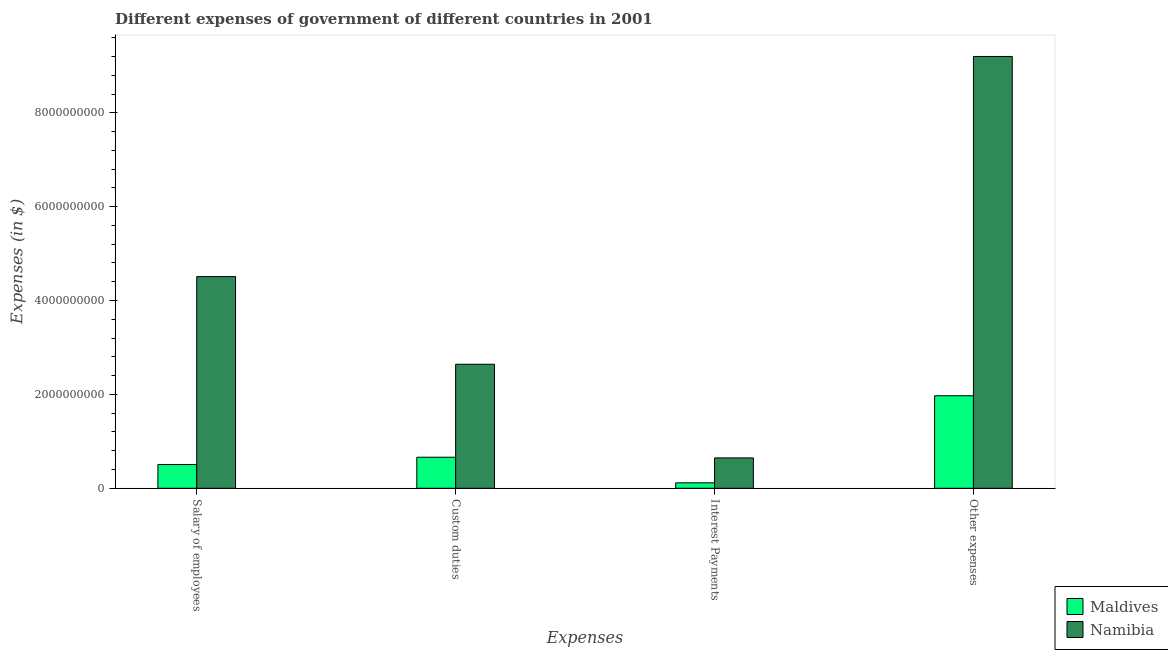Are the number of bars per tick equal to the number of legend labels?
Offer a very short reply. Yes. How many bars are there on the 3rd tick from the left?
Provide a short and direct response. 2. What is the label of the 2nd group of bars from the left?
Provide a short and direct response. Custom duties. What is the amount spent on interest payments in Namibia?
Provide a succinct answer. 6.47e+08. Across all countries, what is the maximum amount spent on interest payments?
Make the answer very short. 6.47e+08. Across all countries, what is the minimum amount spent on interest payments?
Offer a terse response. 1.16e+08. In which country was the amount spent on salary of employees maximum?
Offer a very short reply. Namibia. In which country was the amount spent on other expenses minimum?
Ensure brevity in your answer.  Maldives. What is the total amount spent on salary of employees in the graph?
Provide a short and direct response. 5.02e+09. What is the difference between the amount spent on other expenses in Namibia and that in Maldives?
Offer a very short reply. 7.23e+09. What is the difference between the amount spent on other expenses in Namibia and the amount spent on interest payments in Maldives?
Provide a succinct answer. 9.08e+09. What is the average amount spent on salary of employees per country?
Offer a terse response. 2.51e+09. What is the difference between the amount spent on salary of employees and amount spent on other expenses in Maldives?
Offer a terse response. -1.47e+09. In how many countries, is the amount spent on other expenses greater than 1200000000 $?
Ensure brevity in your answer.  2. What is the ratio of the amount spent on custom duties in Namibia to that in Maldives?
Offer a terse response. 3.99. What is the difference between the highest and the second highest amount spent on salary of employees?
Make the answer very short. 4.00e+09. What is the difference between the highest and the lowest amount spent on custom duties?
Ensure brevity in your answer.  1.98e+09. In how many countries, is the amount spent on custom duties greater than the average amount spent on custom duties taken over all countries?
Give a very brief answer. 1. Is it the case that in every country, the sum of the amount spent on salary of employees and amount spent on interest payments is greater than the sum of amount spent on custom duties and amount spent on other expenses?
Give a very brief answer. No. What does the 1st bar from the left in Custom duties represents?
Give a very brief answer. Maldives. What does the 2nd bar from the right in Custom duties represents?
Your response must be concise. Maldives. Is it the case that in every country, the sum of the amount spent on salary of employees and amount spent on custom duties is greater than the amount spent on interest payments?
Offer a terse response. Yes. How many bars are there?
Give a very brief answer. 8. Are all the bars in the graph horizontal?
Your answer should be compact. No. What is the difference between two consecutive major ticks on the Y-axis?
Your answer should be compact. 2.00e+09. Are the values on the major ticks of Y-axis written in scientific E-notation?
Offer a terse response. No. Does the graph contain grids?
Give a very brief answer. No. How many legend labels are there?
Your answer should be compact. 2. How are the legend labels stacked?
Offer a terse response. Vertical. What is the title of the graph?
Give a very brief answer. Different expenses of government of different countries in 2001. Does "Northern Mariana Islands" appear as one of the legend labels in the graph?
Offer a very short reply. No. What is the label or title of the X-axis?
Keep it short and to the point. Expenses. What is the label or title of the Y-axis?
Offer a terse response. Expenses (in $). What is the Expenses (in $) in Maldives in Salary of employees?
Make the answer very short. 5.06e+08. What is the Expenses (in $) of Namibia in Salary of employees?
Provide a succinct answer. 4.51e+09. What is the Expenses (in $) in Maldives in Custom duties?
Provide a succinct answer. 6.62e+08. What is the Expenses (in $) in Namibia in Custom duties?
Offer a very short reply. 2.64e+09. What is the Expenses (in $) of Maldives in Interest Payments?
Make the answer very short. 1.16e+08. What is the Expenses (in $) of Namibia in Interest Payments?
Give a very brief answer. 6.47e+08. What is the Expenses (in $) of Maldives in Other expenses?
Give a very brief answer. 1.97e+09. What is the Expenses (in $) in Namibia in Other expenses?
Provide a succinct answer. 9.20e+09. Across all Expenses, what is the maximum Expenses (in $) of Maldives?
Ensure brevity in your answer.  1.97e+09. Across all Expenses, what is the maximum Expenses (in $) of Namibia?
Your response must be concise. 9.20e+09. Across all Expenses, what is the minimum Expenses (in $) in Maldives?
Offer a very short reply. 1.16e+08. Across all Expenses, what is the minimum Expenses (in $) in Namibia?
Provide a short and direct response. 6.47e+08. What is the total Expenses (in $) of Maldives in the graph?
Keep it short and to the point. 3.26e+09. What is the total Expenses (in $) of Namibia in the graph?
Your response must be concise. 1.70e+1. What is the difference between the Expenses (in $) of Maldives in Salary of employees and that in Custom duties?
Offer a terse response. -1.56e+08. What is the difference between the Expenses (in $) in Namibia in Salary of employees and that in Custom duties?
Offer a very short reply. 1.87e+09. What is the difference between the Expenses (in $) of Maldives in Salary of employees and that in Interest Payments?
Offer a very short reply. 3.89e+08. What is the difference between the Expenses (in $) in Namibia in Salary of employees and that in Interest Payments?
Make the answer very short. 3.86e+09. What is the difference between the Expenses (in $) of Maldives in Salary of employees and that in Other expenses?
Give a very brief answer. -1.47e+09. What is the difference between the Expenses (in $) in Namibia in Salary of employees and that in Other expenses?
Ensure brevity in your answer.  -4.69e+09. What is the difference between the Expenses (in $) in Maldives in Custom duties and that in Interest Payments?
Offer a very short reply. 5.45e+08. What is the difference between the Expenses (in $) in Namibia in Custom duties and that in Interest Payments?
Offer a very short reply. 2.00e+09. What is the difference between the Expenses (in $) of Maldives in Custom duties and that in Other expenses?
Offer a terse response. -1.31e+09. What is the difference between the Expenses (in $) in Namibia in Custom duties and that in Other expenses?
Offer a terse response. -6.56e+09. What is the difference between the Expenses (in $) of Maldives in Interest Payments and that in Other expenses?
Keep it short and to the point. -1.85e+09. What is the difference between the Expenses (in $) in Namibia in Interest Payments and that in Other expenses?
Give a very brief answer. -8.55e+09. What is the difference between the Expenses (in $) of Maldives in Salary of employees and the Expenses (in $) of Namibia in Custom duties?
Make the answer very short. -2.14e+09. What is the difference between the Expenses (in $) of Maldives in Salary of employees and the Expenses (in $) of Namibia in Interest Payments?
Your answer should be compact. -1.41e+08. What is the difference between the Expenses (in $) of Maldives in Salary of employees and the Expenses (in $) of Namibia in Other expenses?
Keep it short and to the point. -8.69e+09. What is the difference between the Expenses (in $) in Maldives in Custom duties and the Expenses (in $) in Namibia in Interest Payments?
Your response must be concise. 1.44e+07. What is the difference between the Expenses (in $) in Maldives in Custom duties and the Expenses (in $) in Namibia in Other expenses?
Your answer should be compact. -8.54e+09. What is the difference between the Expenses (in $) of Maldives in Interest Payments and the Expenses (in $) of Namibia in Other expenses?
Make the answer very short. -9.08e+09. What is the average Expenses (in $) of Maldives per Expenses?
Your answer should be compact. 8.14e+08. What is the average Expenses (in $) in Namibia per Expenses?
Your answer should be very brief. 4.25e+09. What is the difference between the Expenses (in $) in Maldives and Expenses (in $) in Namibia in Salary of employees?
Make the answer very short. -4.00e+09. What is the difference between the Expenses (in $) of Maldives and Expenses (in $) of Namibia in Custom duties?
Make the answer very short. -1.98e+09. What is the difference between the Expenses (in $) in Maldives and Expenses (in $) in Namibia in Interest Payments?
Provide a succinct answer. -5.31e+08. What is the difference between the Expenses (in $) in Maldives and Expenses (in $) in Namibia in Other expenses?
Provide a succinct answer. -7.23e+09. What is the ratio of the Expenses (in $) in Maldives in Salary of employees to that in Custom duties?
Make the answer very short. 0.76. What is the ratio of the Expenses (in $) of Namibia in Salary of employees to that in Custom duties?
Keep it short and to the point. 1.71. What is the ratio of the Expenses (in $) in Maldives in Salary of employees to that in Interest Payments?
Your answer should be very brief. 4.34. What is the ratio of the Expenses (in $) of Namibia in Salary of employees to that in Interest Payments?
Keep it short and to the point. 6.97. What is the ratio of the Expenses (in $) in Maldives in Salary of employees to that in Other expenses?
Provide a short and direct response. 0.26. What is the ratio of the Expenses (in $) in Namibia in Salary of employees to that in Other expenses?
Give a very brief answer. 0.49. What is the ratio of the Expenses (in $) of Maldives in Custom duties to that in Interest Payments?
Make the answer very short. 5.68. What is the ratio of the Expenses (in $) of Namibia in Custom duties to that in Interest Payments?
Offer a very short reply. 4.08. What is the ratio of the Expenses (in $) in Maldives in Custom duties to that in Other expenses?
Your answer should be compact. 0.34. What is the ratio of the Expenses (in $) in Namibia in Custom duties to that in Other expenses?
Your answer should be compact. 0.29. What is the ratio of the Expenses (in $) in Maldives in Interest Payments to that in Other expenses?
Your response must be concise. 0.06. What is the ratio of the Expenses (in $) in Namibia in Interest Payments to that in Other expenses?
Your answer should be very brief. 0.07. What is the difference between the highest and the second highest Expenses (in $) in Maldives?
Keep it short and to the point. 1.31e+09. What is the difference between the highest and the second highest Expenses (in $) in Namibia?
Give a very brief answer. 4.69e+09. What is the difference between the highest and the lowest Expenses (in $) of Maldives?
Offer a very short reply. 1.85e+09. What is the difference between the highest and the lowest Expenses (in $) in Namibia?
Provide a succinct answer. 8.55e+09. 